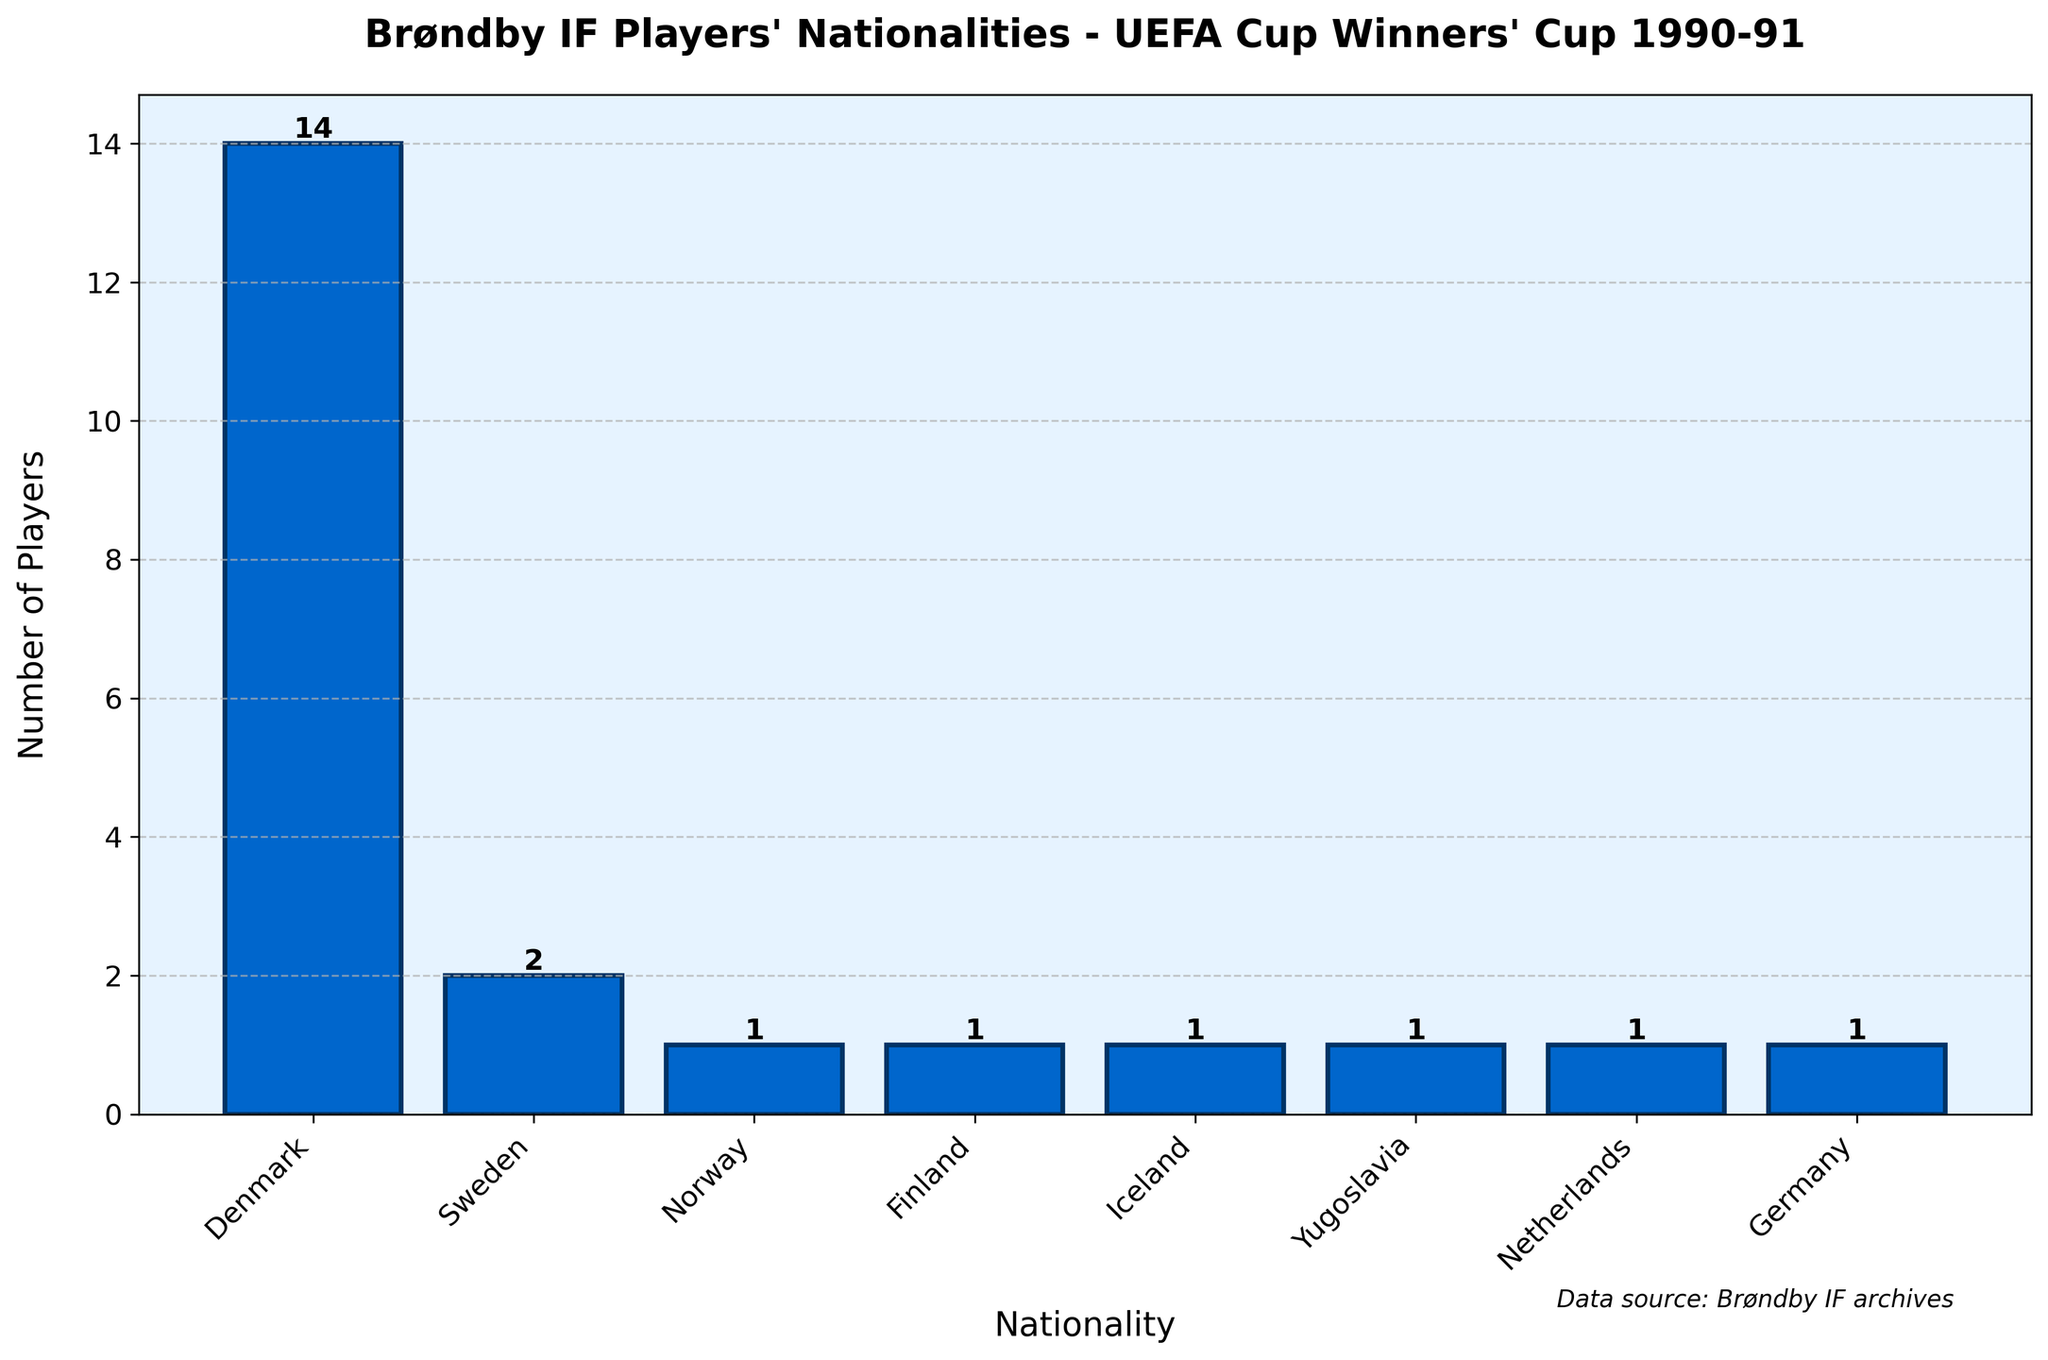How many more Danish players were there compared to Swedish players? There were 14 Danish players and 2 Swedish players. To find out how many more Danish players there were, subtract the number of Swedish players from the number of Danish players. 14 - 2 = 12
Answer: 12 What is the total number of players from Scandinavian countries in the squad? Scandinavian countries represented in the squad include Denmark, Sweden, Norway, and Finland. Add the number of players from these countries: 14 (Denmark) + 2 (Sweden) + 1 (Norway) + 1 (Finland) = 18
Answer: 18 Which nationality had the smallest representation in the squad? From the bar chart, nationalities with a count of 1 player each are Norway, Finland, Iceland, Yugoslavia, Netherlands, and Germany. Among these, each had the smallest representation in the squad.
Answer: Norway, Finland, Iceland, Yugoslavia, Netherlands, Germany How many nationalities are represented in the squad? Counting the distinct nationalities listed in the bar chart: Denmark, Sweden, Norway, Finland, Iceland, Yugoslavia, Netherlands, Germany. There are 8 nationalities.
Answer: 8 What percentage of the squad was Danish players? First, find the total number of players: 14 (Denmark) + 2 (Sweden) + 1 (Norway) + 1 (Finland) + 1 (Iceland) + 1 (Yugoslavia) + 1 (Netherlands) + 1 (Germany) = 22. Calculate the percentage: (14 / 22) * 100 ≈ 63.64%.
Answer: 63.64% Were there more players from Germany or Iceland? The bar chart shows both Germany and Iceland had 1 player each. Therefore, the number of players is the same for both countries.
Answer: Equal Which nationality contributed the tallest single bar? The bar representing Danish players is the tallest in the chart with a height corresponding to 14 players.
Answer: Denmark Is the sum of Finnish and Icelandic players greater or less than the number of Swedish players? The number of Finnish players is 1, and the number of Icelandic players is also 1. Adding these, 1 + 1 = 2, which is equal to the number of Swedish players (2).
Answer: Equal 